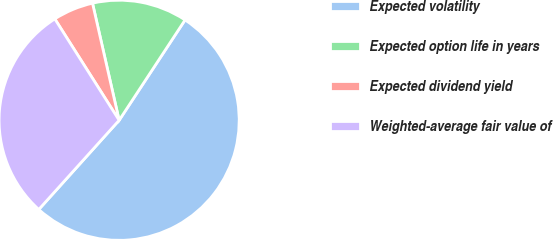<chart> <loc_0><loc_0><loc_500><loc_500><pie_chart><fcel>Expected volatility<fcel>Expected option life in years<fcel>Expected dividend yield<fcel>Weighted-average fair value of<nl><fcel>52.42%<fcel>12.81%<fcel>5.44%<fcel>29.33%<nl></chart> 